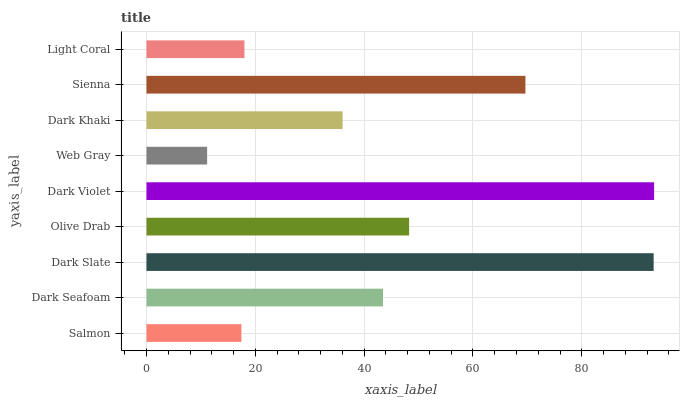Is Web Gray the minimum?
Answer yes or no. Yes. Is Dark Violet the maximum?
Answer yes or no. Yes. Is Dark Seafoam the minimum?
Answer yes or no. No. Is Dark Seafoam the maximum?
Answer yes or no. No. Is Dark Seafoam greater than Salmon?
Answer yes or no. Yes. Is Salmon less than Dark Seafoam?
Answer yes or no. Yes. Is Salmon greater than Dark Seafoam?
Answer yes or no. No. Is Dark Seafoam less than Salmon?
Answer yes or no. No. Is Dark Seafoam the high median?
Answer yes or no. Yes. Is Dark Seafoam the low median?
Answer yes or no. Yes. Is Light Coral the high median?
Answer yes or no. No. Is Olive Drab the low median?
Answer yes or no. No. 